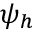<formula> <loc_0><loc_0><loc_500><loc_500>\psi _ { h }</formula> 